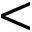Convert formula to latex. <formula><loc_0><loc_0><loc_500><loc_500><</formula> 